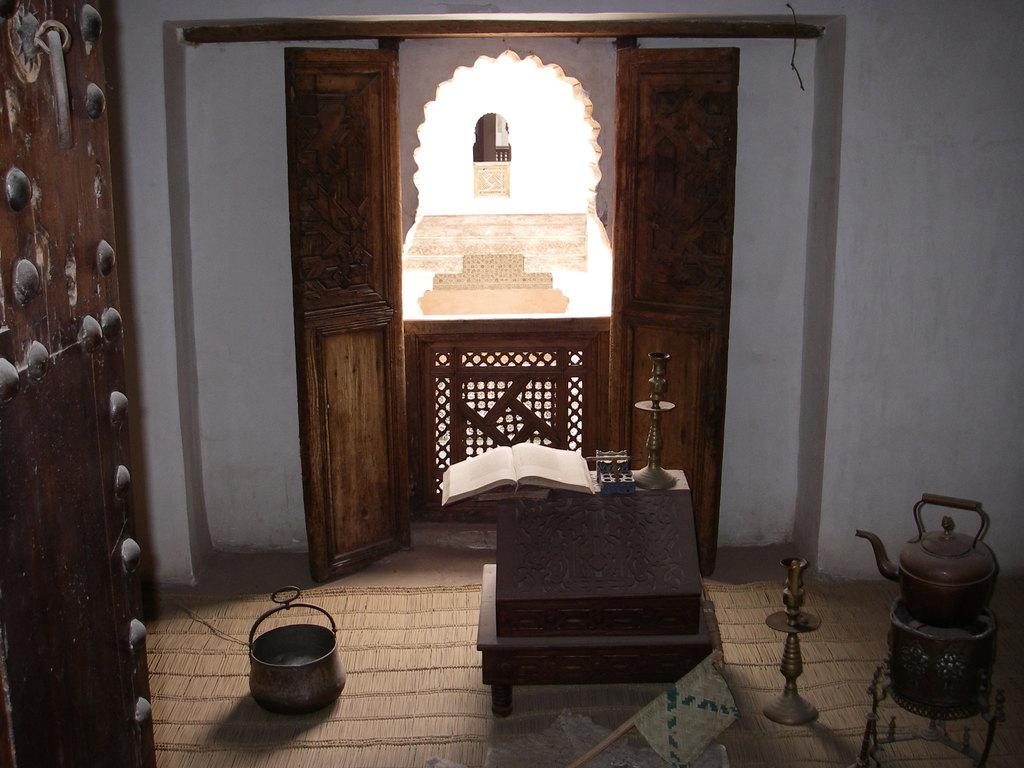Could you give a brief overview of what you see in this image? In this image we can see there are few objects placed on the mat on a floor. On the left side of the image there is a wooden door. In the background there is a wall and an open door. 